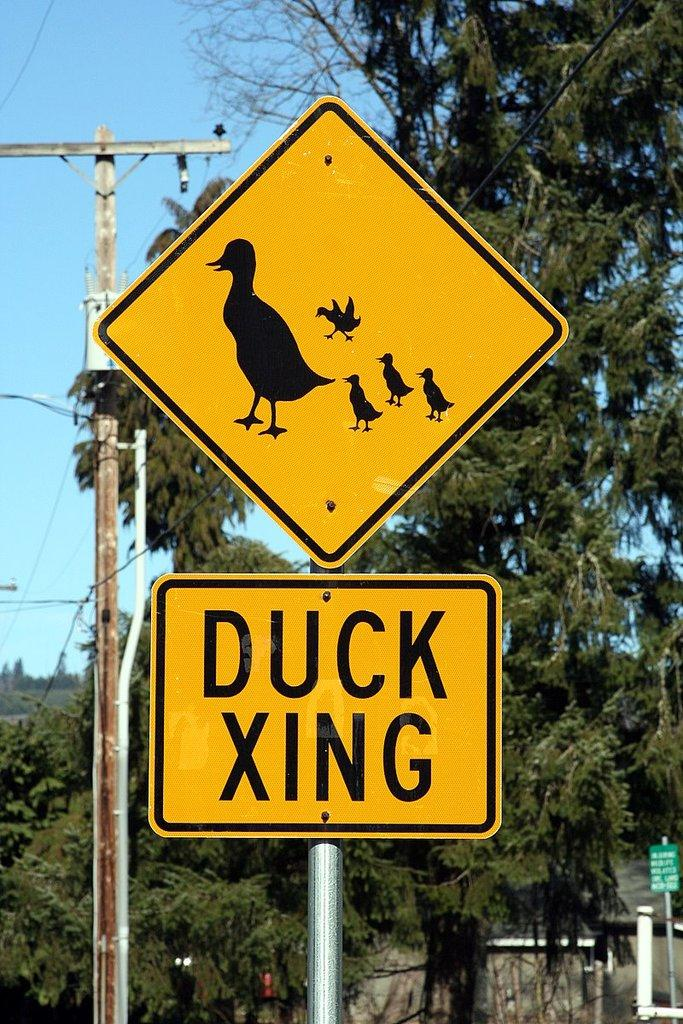<image>
Relay a brief, clear account of the picture shown. street sign warning about duck crossing the street 